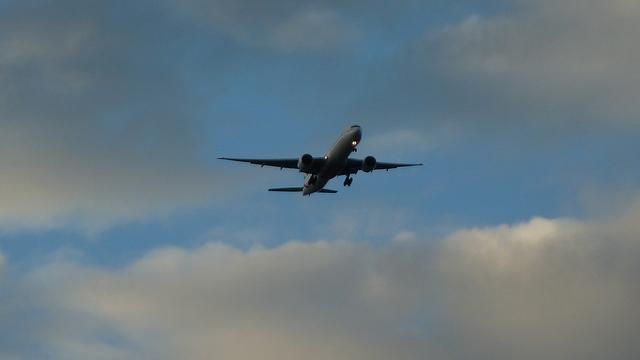Is this an airshow?
Write a very short answer. No. How many clouds are there?
Give a very brief answer. Many. Is it cloudy or clear?
Be succinct. Cloudy. How many planes have propellers?
Write a very short answer. 1. Does the plane have landing gear out?
Short answer required. Yes. Is this a twin engines jet?
Answer briefly. Yes. What is the weather like?
Keep it brief. Cloudy. What is in the picture?
Write a very short answer. Airplane. Is this plane dumping anything?
Write a very short answer. No. What does the cloud on the right look like?
Quick response, please. Cloud. 